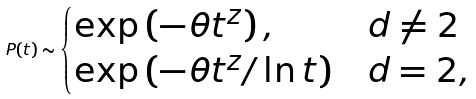Convert formula to latex. <formula><loc_0><loc_0><loc_500><loc_500>P ( t ) \sim \begin{cases} \exp \left ( - \theta t ^ { z } \right ) , & d \neq 2 \\ \exp \left ( - \theta t ^ { z } / \ln t \right ) & d = 2 , \end{cases}</formula> 